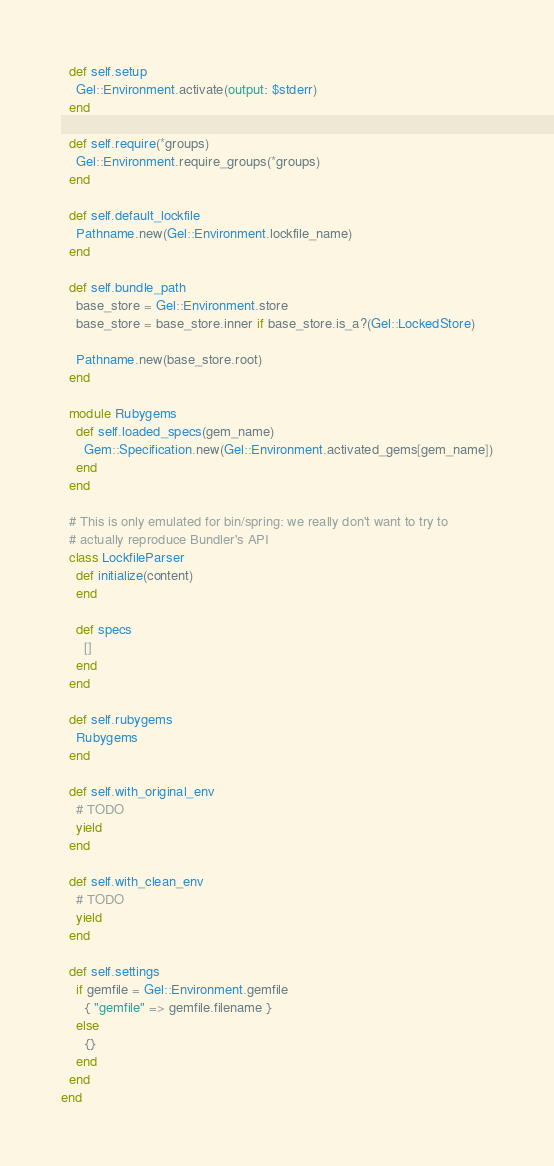<code> <loc_0><loc_0><loc_500><loc_500><_Ruby_>  def self.setup
    Gel::Environment.activate(output: $stderr)
  end

  def self.require(*groups)
    Gel::Environment.require_groups(*groups)
  end

  def self.default_lockfile
    Pathname.new(Gel::Environment.lockfile_name)
  end

  def self.bundle_path
    base_store = Gel::Environment.store
    base_store = base_store.inner if base_store.is_a?(Gel::LockedStore)

    Pathname.new(base_store.root)
  end

  module Rubygems
    def self.loaded_specs(gem_name)
      Gem::Specification.new(Gel::Environment.activated_gems[gem_name])
    end
  end

  # This is only emulated for bin/spring: we really don't want to try to
  # actually reproduce Bundler's API
  class LockfileParser
    def initialize(content)
    end

    def specs
      []
    end
  end

  def self.rubygems
    Rubygems
  end

  def self.with_original_env
    # TODO
    yield
  end

  def self.with_clean_env
    # TODO
    yield
  end

  def self.settings
    if gemfile = Gel::Environment.gemfile
      { "gemfile" => gemfile.filename }
    else
      {}
    end
  end
end
</code> 